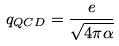Convert formula to latex. <formula><loc_0><loc_0><loc_500><loc_500>q _ { Q C D } = { \frac { e } { \sqrt { 4 \pi \alpha } } }</formula> 